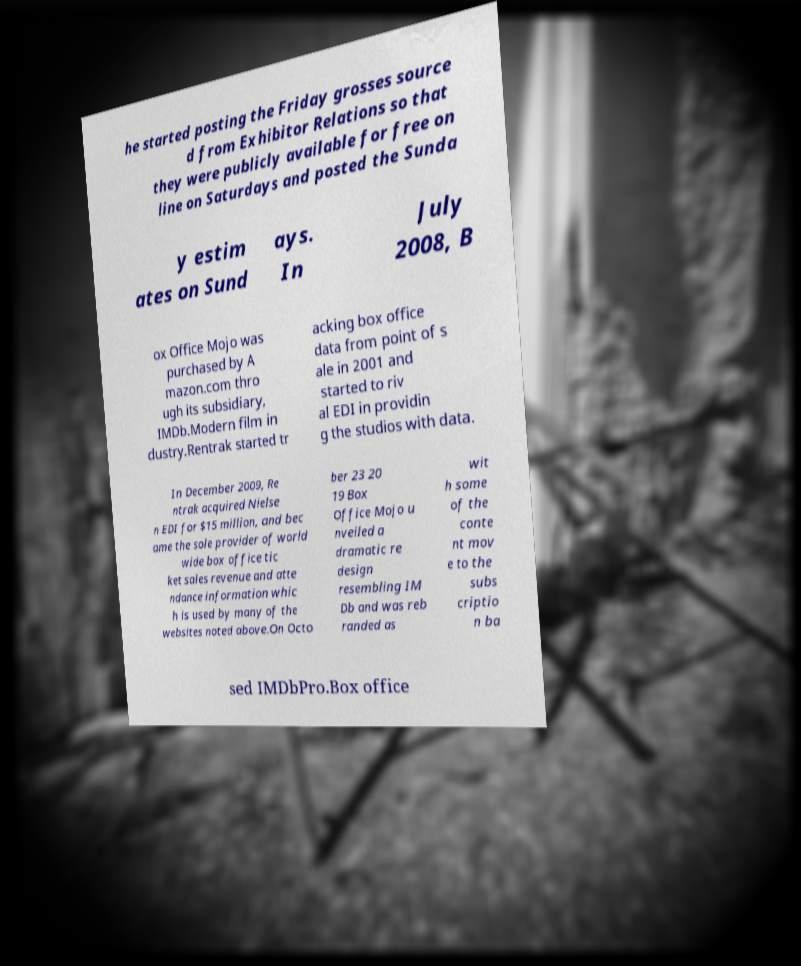For documentation purposes, I need the text within this image transcribed. Could you provide that? he started posting the Friday grosses source d from Exhibitor Relations so that they were publicly available for free on line on Saturdays and posted the Sunda y estim ates on Sund ays. In July 2008, B ox Office Mojo was purchased by A mazon.com thro ugh its subsidiary, IMDb.Modern film in dustry.Rentrak started tr acking box office data from point of s ale in 2001 and started to riv al EDI in providin g the studios with data. In December 2009, Re ntrak acquired Nielse n EDI for $15 million, and bec ame the sole provider of world wide box office tic ket sales revenue and atte ndance information whic h is used by many of the websites noted above.On Octo ber 23 20 19 Box Office Mojo u nveiled a dramatic re design resembling IM Db and was reb randed as wit h some of the conte nt mov e to the subs criptio n ba sed IMDbPro.Box office 